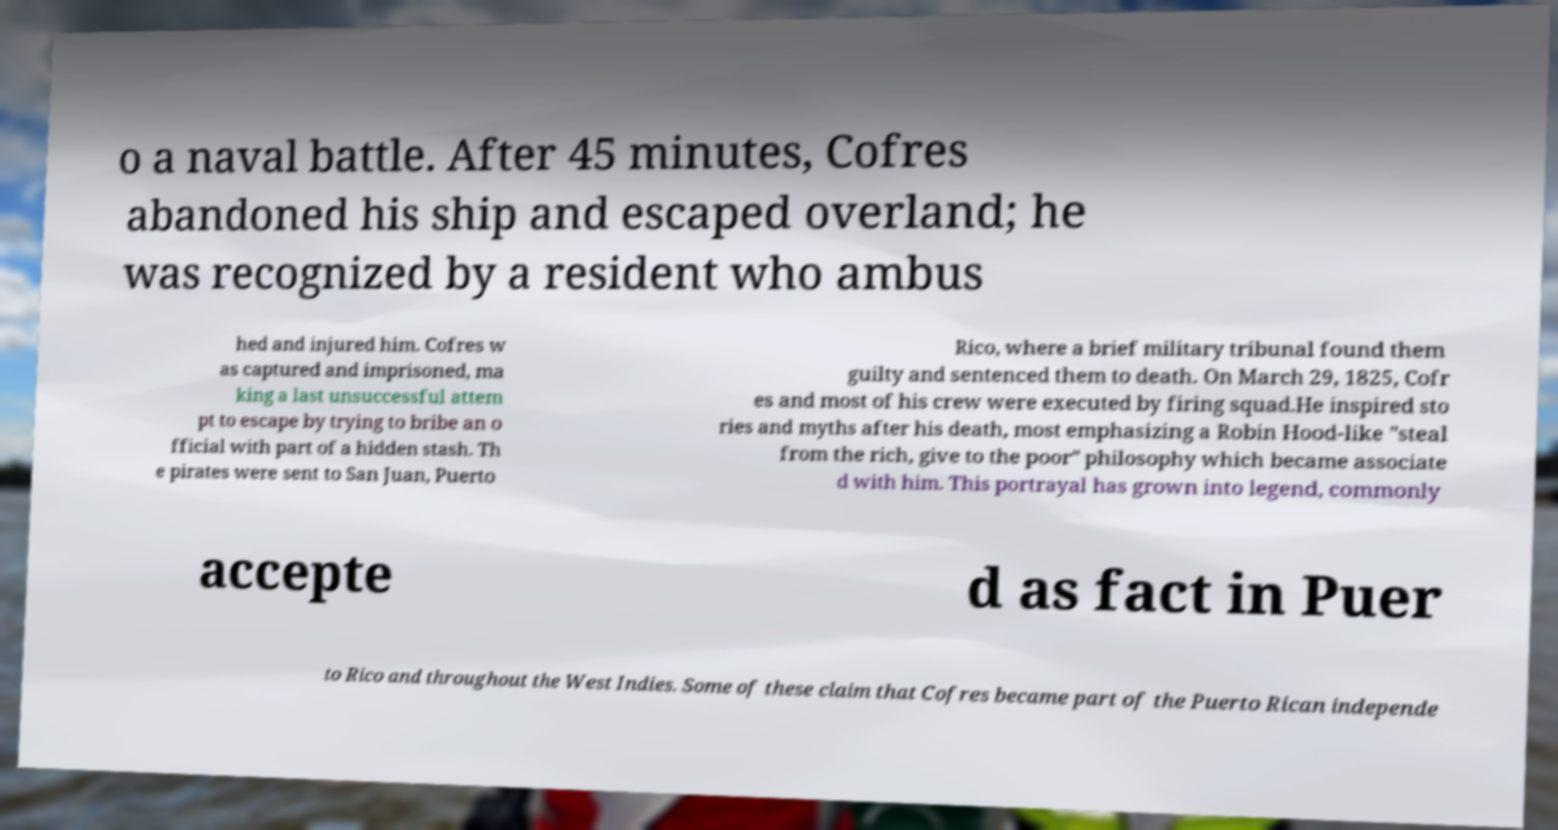Could you assist in decoding the text presented in this image and type it out clearly? o a naval battle. After 45 minutes, Cofres abandoned his ship and escaped overland; he was recognized by a resident who ambus hed and injured him. Cofres w as captured and imprisoned, ma king a last unsuccessful attem pt to escape by trying to bribe an o fficial with part of a hidden stash. Th e pirates were sent to San Juan, Puerto Rico, where a brief military tribunal found them guilty and sentenced them to death. On March 29, 1825, Cofr es and most of his crew were executed by firing squad.He inspired sto ries and myths after his death, most emphasizing a Robin Hood-like "steal from the rich, give to the poor" philosophy which became associate d with him. This portrayal has grown into legend, commonly accepte d as fact in Puer to Rico and throughout the West Indies. Some of these claim that Cofres became part of the Puerto Rican independe 